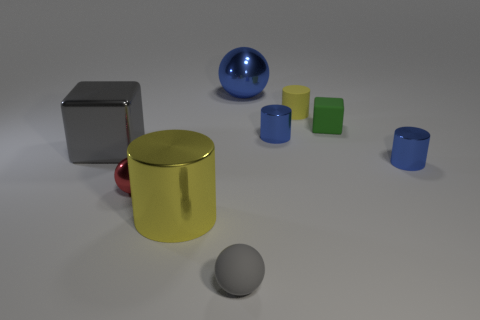How are the objects in the image different from each other? The objects vary in several ways; they have different colors, materials, and reflectivity. For instance, some objects have a matte finish like the blue and green cylinders, while others are highly reflective, like the silver cube and golden cylinder. Additionally, the shapes differ between cylindrical, spherical, and cubic. 